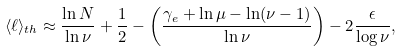<formula> <loc_0><loc_0><loc_500><loc_500>\langle \mathcal { \ell } \rangle _ { t h } \approx \frac { \ln N } { \ln \nu } + \frac { 1 } { 2 } - \left ( \frac { \gamma _ { e } + \ln \mu - \ln ( \nu - 1 ) } { \ln \nu } \right ) - 2 \frac { \epsilon } { \log \nu } ,</formula> 